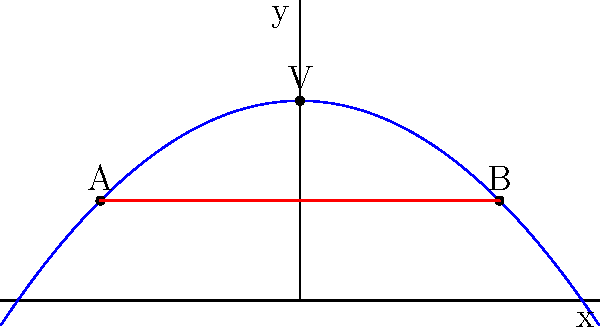A new design for solar panels follows the shape of a parabola with the equation $y = -\frac{1}{4}x^2 + 2$. The panel extends from point A $(-2, f(-2))$ to point B $(2, f(2))$. Calculate the difference in surface area between the parabolic panel and a flat panel connecting points A and B. How much additional solar energy can be captured annually if each square meter of panel surface area generates 200 kWh per year? To solve this problem, we'll follow these steps:

1) Find the length of the parabolic arc:
   The arc length of a curve $y=f(x)$ from $a$ to $b$ is given by:
   $$L = \int_{a}^{b} \sqrt{1 + [f'(x)]^2} dx$$
   Here, $f(x) = -\frac{1}{4}x^2 + 2$ and $f'(x) = -\frac{1}{2}x$
   $$L = \int_{-2}^{2} \sqrt{1 + (\frac{1}{2}x)^2} dx$$
   This integral can be solved numerically, giving $L \approx 4.4721$ units.

2) Find the length of the straight line AB:
   Using the distance formula:
   $$AB = \sqrt{(2-(-2))^2 + (f(2)-f(-2))^2} = \sqrt{4^2 + 0^2} = 4$$ units

3) Calculate the difference in length:
   Difference = $4.4721 - 4 = 0.4721$ units

4) Convert this to area, assuming a unit depth:
   Additional area = $0.4721 \times 1 = 0.4721$ square units

5) Calculate additional energy capture:
   $0.4721 \text{ m}^2 \times 200 \text{ kWh/m}^2/\text{year} = 94.42 \text{ kWh/year}$
Answer: 94.42 kWh/year 